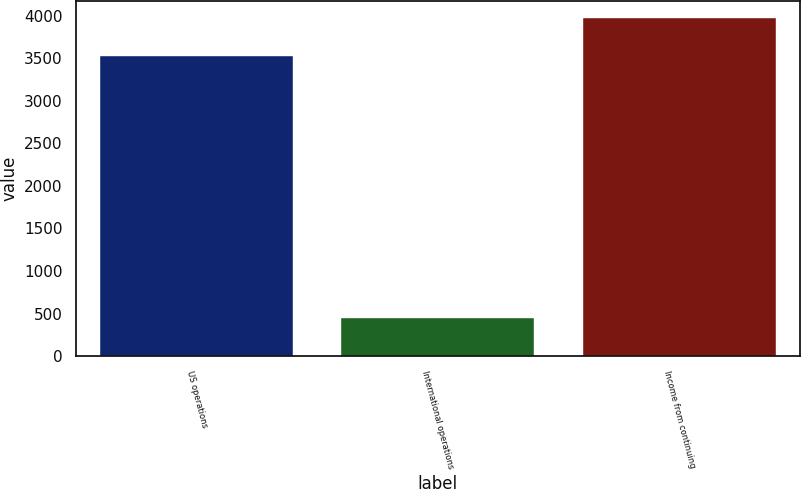Convert chart to OTSL. <chart><loc_0><loc_0><loc_500><loc_500><bar_chart><fcel>US operations<fcel>International operations<fcel>Income from continuing<nl><fcel>3531<fcel>445<fcel>3976<nl></chart> 